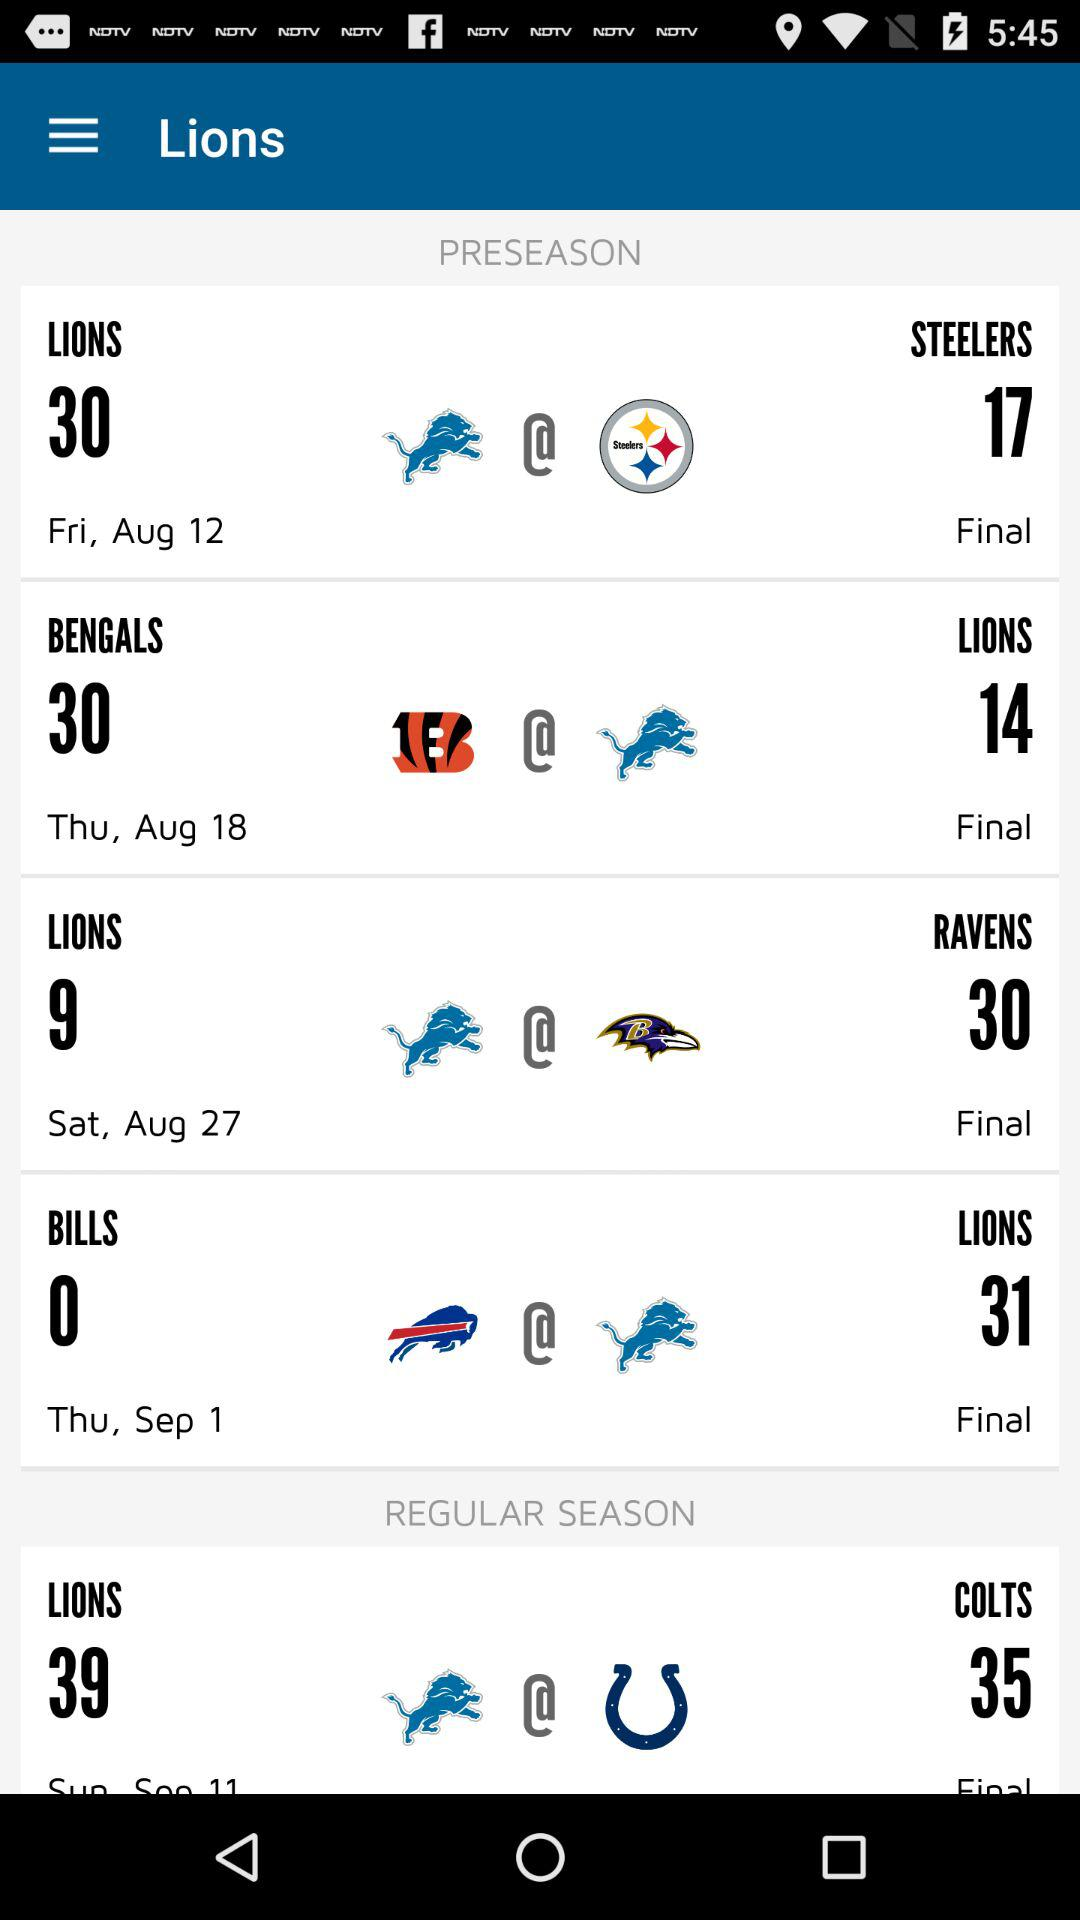When is the preseason game between the "LIONS" and the "STEELERS"? It is on Friday, August 12. 